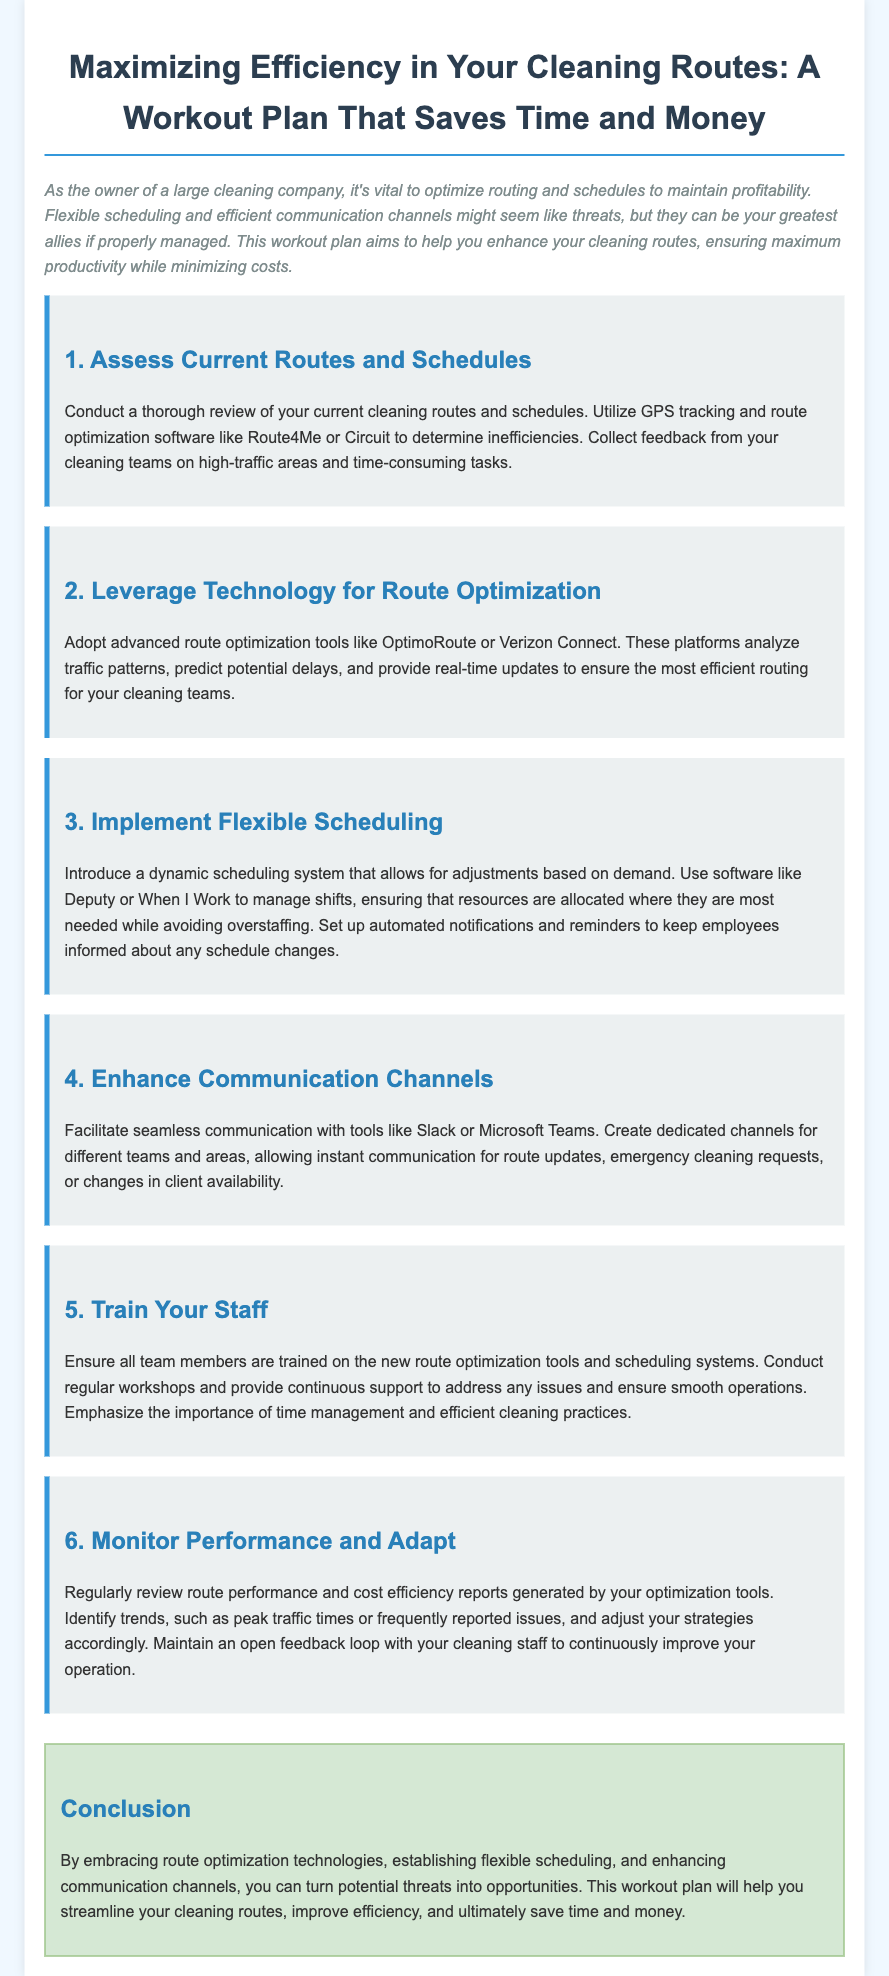What is the purpose of the workout plan? The purpose of the workout plan is to help enhance cleaning routes, ensuring maximum productivity while minimizing costs.
Answer: Enhance cleaning routes What technology is recommended for route optimization? The document mentions advanced route optimization tools like OptimoRoute or Verizon Connect for efficient route management.
Answer: OptimoRoute or Verizon Connect Which software can be used for dynamic scheduling? The document suggests using software like Deputy or When I Work to manage shifts.
Answer: Deputy or When I Work What is the first step in the workout plan? The first step in the workout plan is to conduct a thorough review of current cleaning routes and schedules.
Answer: Assess Current Routes and Schedules How should performance be monitored? Performance should be monitored by regularly reviewing route performance and cost efficiency reports generated by optimization tools.
Answer: Route performance reports What is emphasized during the staff training? The document emphasizes the importance of time management and efficient cleaning practices during staff training.
Answer: Time management and efficient cleaning practices What is a suggested communication tool? The document suggests using tools like Slack or Microsoft Teams for seamless communication among teams.
Answer: Slack or Microsoft Teams What is the conclusion of the workout plan? The conclusion states that route optimization technologies, flexible scheduling, and enhanced communication can turn threats into opportunities.
Answer: Turn threats into opportunities 